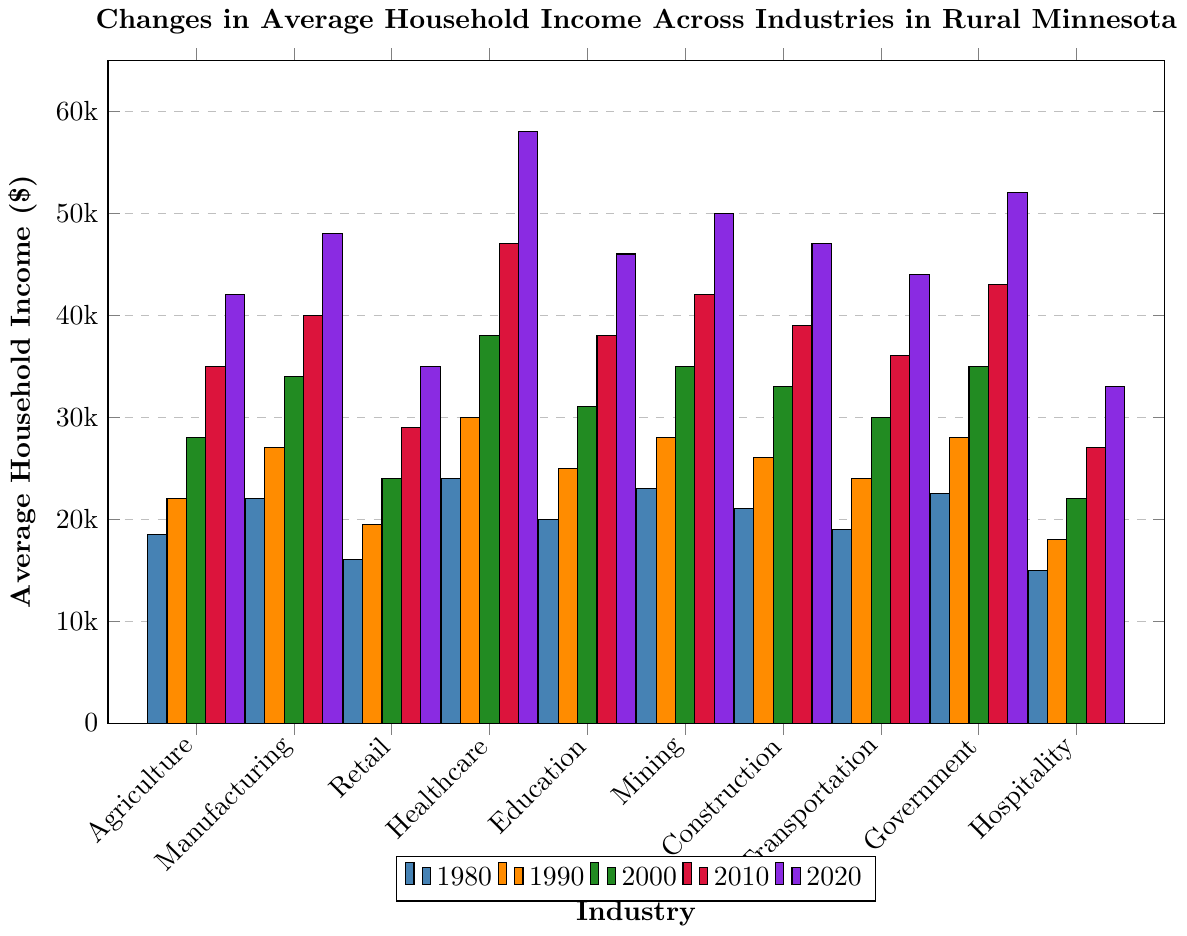What's the average household income for the Agriculture industry in the year 2020? Looking at the Agriculture bar for 2020, we see that the average household income is $42,000.
Answer: $42,000 Which industry had the highest average household income in 1980? Among all the industries in 1980, Healthcare has the highest average household income with $24,000.
Answer: Healthcare How much did the average household income for the Mining industry increase from 1980 to 2020? The average household income in Mining increased from $23,000 in 1980 to $50,000 in 2020. The increase is $50,000 - $23,000 = $27,000.
Answer: $27,000 Which two industries had the closest average household incomes in 2000? By comparing all industries in 2000, we find that the average household incomes for Construction ($33,000) and Transportation ($30,000) were the closest, with a difference of $3,000.
Answer: Construction and Transportation What is the average change in household income across all industries from 1990 to 2000? For each industry, calculate the change between 1990 and 2000, then find the average. The changes are: Agriculture $28,000-$22,000 = $6,000, Manufacturing $34,000-$27,000 = $7,000, Retail $24,000-$19,500 = $4,500, Healthcare $38,000-$30,000 = $8,000, Education $31,000-$25,000 = $6,000, Mining $35,000-$28,000 = $7,000, Construction $33,000-$26,000 = $7,000, Transportation $30,000-$24,000 = $6,000, Government $35,000-$28,000 = $7,000, Hospitality $22,000-$18,000 = $4,000. The average change is (6,000+7,000+4,500+8,000+6,000+7,000+7,000+6,000+7,000+4,000) / 10 = $6,150.
Answer: $6,150 Which industry had the lowest average household income in 2020? Hospitality had the lowest average household income in 2020 with $33,000.
Answer: Hospitality How does the change in average household income compare between Healthcare and Hospitality from 1980 to 2020? Healthcare increased from $24,000 in 1980 to $58,000 in 2020, a change of $34,000. Hospitality increased from $15,000 in 1980 to $33,000 in 2020, a change of $18,000. Therefore, Healthcare had a greater increase compared to Hospitality.
Answer: Healthcare had a greater increase In what decade did the Retail industry see its largest increase in average household income? Between each decade: 1980-1990 ($19,500-$16,000 = $3,500), 1990-2000 ($24,000-$19,500 = $4,500), 2000-2010 ($29,000-$24,000 = $5,000), 2010-2020 ($35,000-$29,000 = $6,000). The largest increase happened from 2010 to 2020 with an increase of $6,000.
Answer: 2010-2020 What is the difference in average household income between Education and Manufacturing in 2020? In 2020, Education has an average household income of $46,000 and Manufacturing has $48,000. The difference is $48,000 - $46,000 = $2,000.
Answer: $2,000 Which decade had the most growth in household income for the Government industry? Government income growth per decade: 1980-1990 ($28,000-$22,500 = $5,500), 1990-2000 ($35,000-$28,000 = $7,000), 2000-2010 ($43,000-$35,000 = $8,000), 2010-2020 ($52,000-$43,000 = $9,000). The decade with the most growth was 2010-2020 with $9,000.
Answer: 2010-2020 